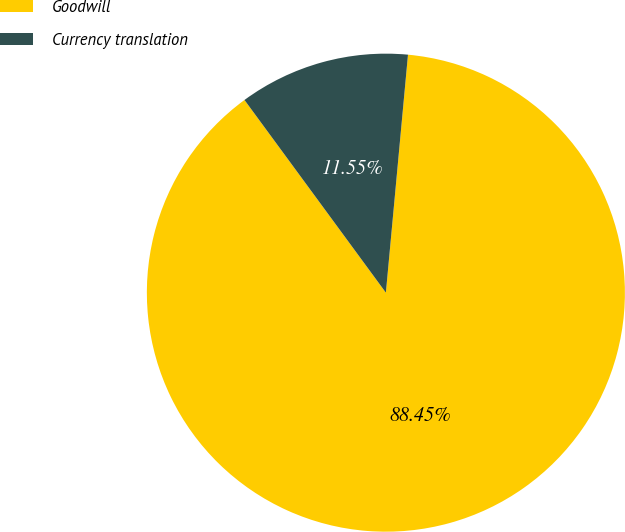Convert chart to OTSL. <chart><loc_0><loc_0><loc_500><loc_500><pie_chart><fcel>Goodwill<fcel>Currency translation<nl><fcel>88.45%<fcel>11.55%<nl></chart> 